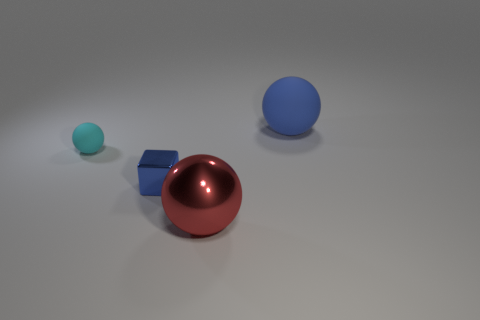Add 3 red balls. How many objects exist? 7 Subtract all blocks. How many objects are left? 3 Add 1 large blue objects. How many large blue objects are left? 2 Add 4 metallic things. How many metallic things exist? 6 Subtract 1 blue blocks. How many objects are left? 3 Subtract all blue metallic cubes. Subtract all small cubes. How many objects are left? 2 